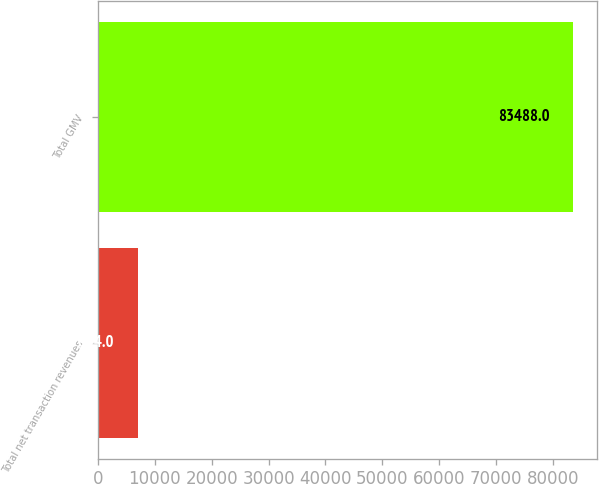<chart> <loc_0><loc_0><loc_500><loc_500><bar_chart><fcel>Total net transaction revenues<fcel>Total GMV<nl><fcel>7044<fcel>83488<nl></chart> 